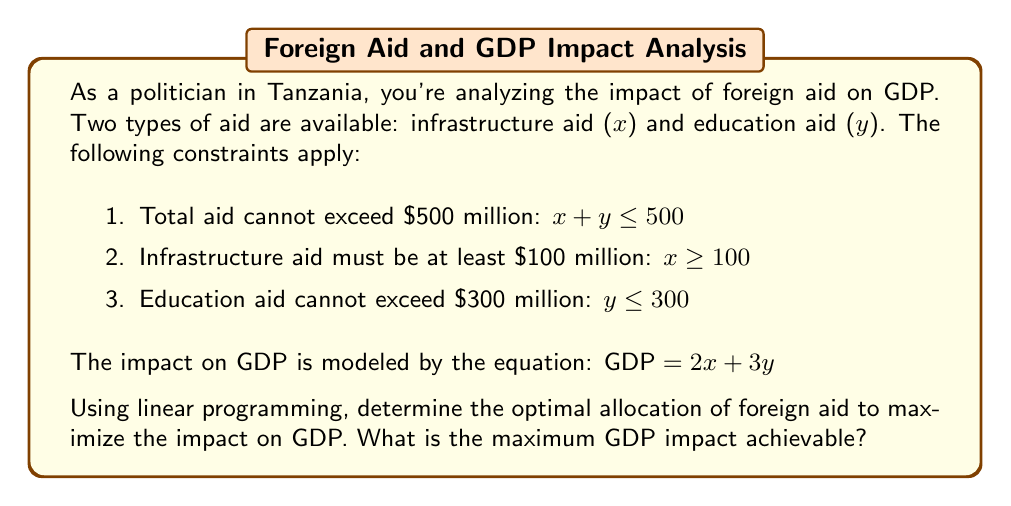Solve this math problem. To solve this linear programming problem, we'll follow these steps:

1. Identify the objective function and constraints:
   Objective function: Maximize $GDP = 2x + 3y$
   Constraints:
   $x + y \leq 500$
   $x \geq 100$
   $y \leq 300$
   $x, y \geq 0$ (implicit non-negativity constraint)

2. Plot the feasible region:
   [asy]
   import geometry;
   
   size(200);
   
   real xmax = 550;
   real ymax = 350;
   
   draw((0,0)--(xmax,0)--(xmax,ymax)--(0,ymax)--cycle);
   draw((0,300)--(500,300), dashed);
   draw((100,0)--(100,ymax), dashed);
   draw((0,500)--(500,0), dashed);
   
   fill((100,0)--(100,300)--(400,300)--(500,200)--(500,0)--cycle, lightgray);
   
   label("$x + y = 500$", (250,250), NE);
   label("$y = 300$", (250,300), N);
   label("$x = 100$", (100,150), E);
   
   dot((100,300));
   dot((400,300));
   dot((500,200));
   
   label("A (100,300)", (100,300), NW);
   label("B (400,300)", (400,300), NE);
   label("C (500,200)", (500,200), SE);
   
   xaxis("x", 0, xmax, Arrow);
   yaxis("y", 0, ymax, Arrow);
   [/asy]

3. Identify the corner points of the feasible region:
   A (100, 300)
   B (400, 300)
   C (500, 200)

4. Evaluate the objective function at each corner point:
   A: $GDP = 2(100) + 3(300) = 1100$
   B: $GDP = 2(400) + 3(300) = 1700$
   C: $GDP = 2(500) + 3(200) = 1600$

5. Select the point that maximizes the objective function:
   Point B (400, 300) yields the maximum GDP impact of 1700.

Therefore, the optimal allocation is $400 million for infrastructure aid and $300 million for education aid, resulting in a maximum GDP impact of $1700 million.
Answer: The maximum GDP impact achievable is $1700 million, with an optimal allocation of $400 million for infrastructure aid and $300 million for education aid. 